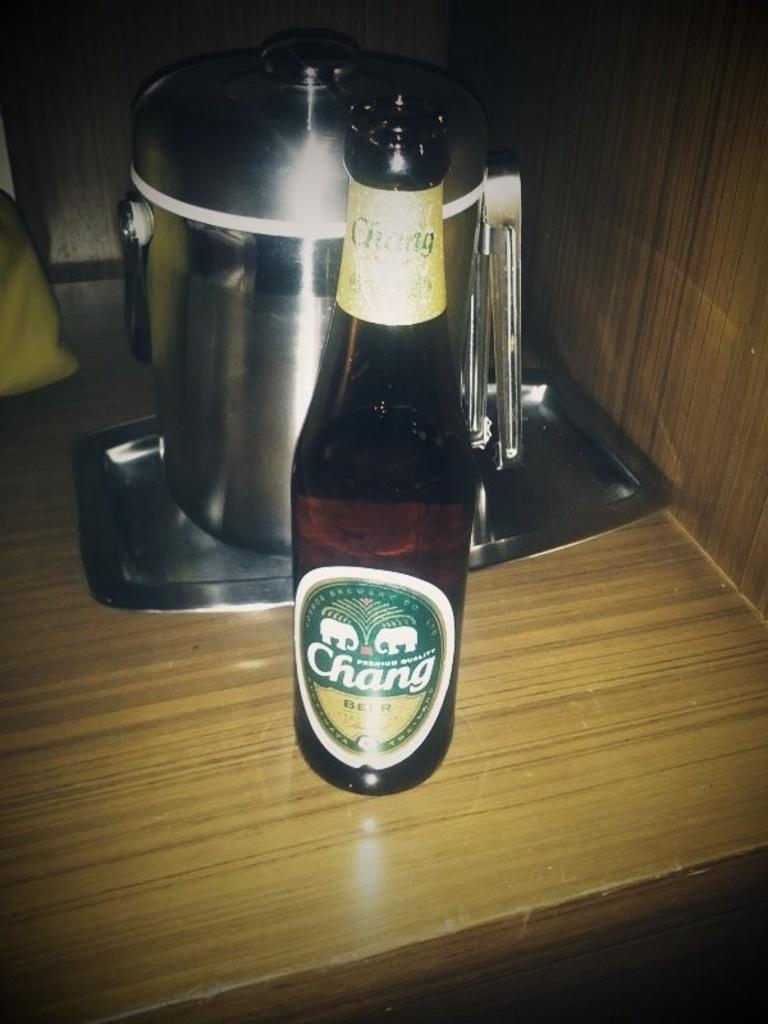Describe this image in one or two sentences. In this image, there is a table which is in yellow color, on that table there is a wine which is in black color, there are some utensils which are in ash color kept on the table. 